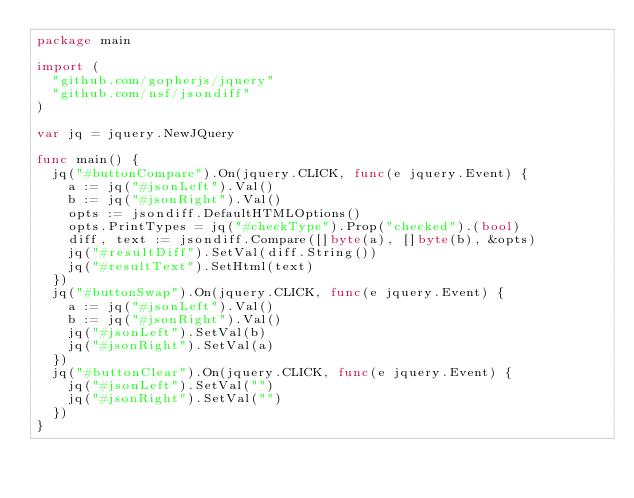Convert code to text. <code><loc_0><loc_0><loc_500><loc_500><_Go_>package main

import (
	"github.com/gopherjs/jquery"
	"github.com/nsf/jsondiff"
)

var jq = jquery.NewJQuery

func main() {
	jq("#buttonCompare").On(jquery.CLICK, func(e jquery.Event) {
		a := jq("#jsonLeft").Val()
		b := jq("#jsonRight").Val()
		opts := jsondiff.DefaultHTMLOptions()
		opts.PrintTypes = jq("#checkType").Prop("checked").(bool)
		diff, text := jsondiff.Compare([]byte(a), []byte(b), &opts)
		jq("#resultDiff").SetVal(diff.String())
		jq("#resultText").SetHtml(text)
	})
	jq("#buttonSwap").On(jquery.CLICK, func(e jquery.Event) {
		a := jq("#jsonLeft").Val()
		b := jq("#jsonRight").Val()
		jq("#jsonLeft").SetVal(b)
		jq("#jsonRight").SetVal(a)
	})
	jq("#buttonClear").On(jquery.CLICK, func(e jquery.Event) {
		jq("#jsonLeft").SetVal("")
		jq("#jsonRight").SetVal("")
	})
}
</code> 